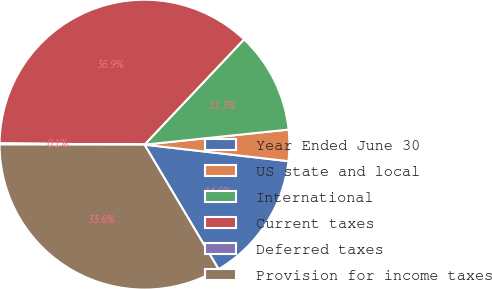Convert chart to OTSL. <chart><loc_0><loc_0><loc_500><loc_500><pie_chart><fcel>Year Ended June 30<fcel>US state and local<fcel>International<fcel>Current taxes<fcel>Deferred taxes<fcel>Provision for income taxes<nl><fcel>14.64%<fcel>3.48%<fcel>11.29%<fcel>36.91%<fcel>0.12%<fcel>33.56%<nl></chart> 